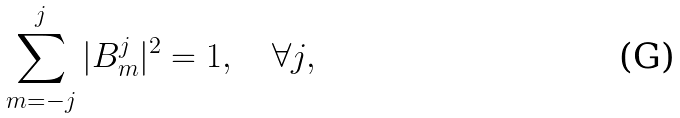Convert formula to latex. <formula><loc_0><loc_0><loc_500><loc_500>\sum _ { m = - j } ^ { j } | B _ { m } ^ { j } | ^ { 2 } = 1 , \quad \forall j ,</formula> 